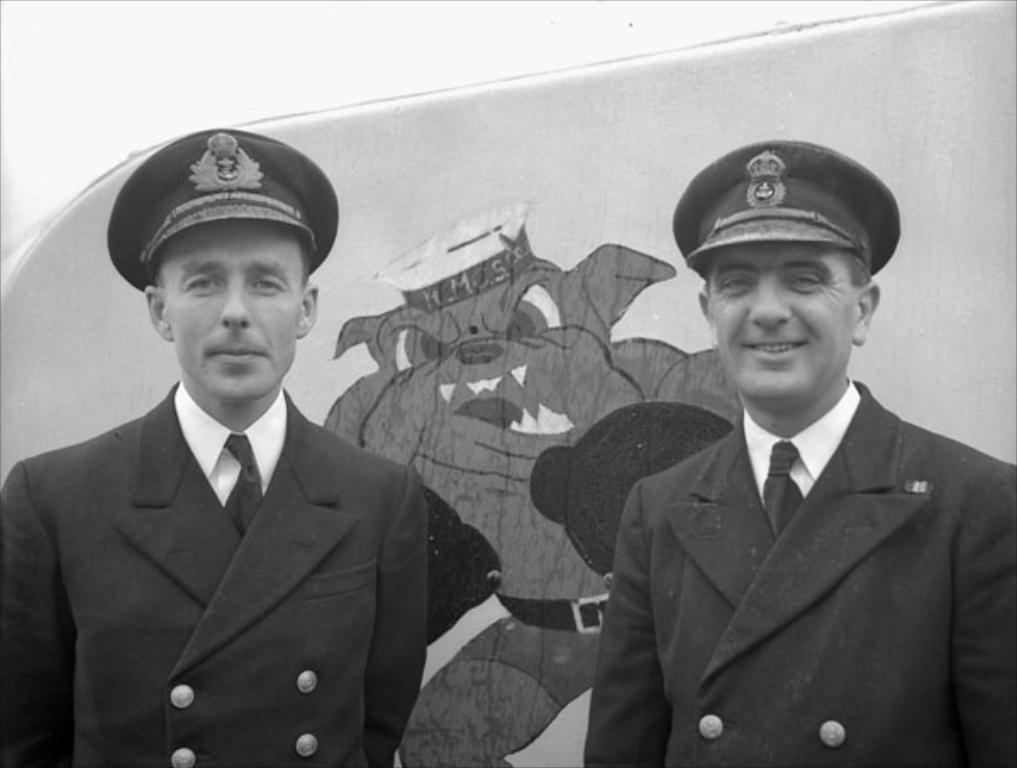How many people are present in the image? There are two people in the image. What are the people wearing? Both people are wearing suits and hats. What can be seen in the background of the image? There is a cartoon in the background of the image. What type of poison is being used by the people in the image? There is no indication of poison or any dangerous substances in the image. The people are simply wearing suits and hats. 